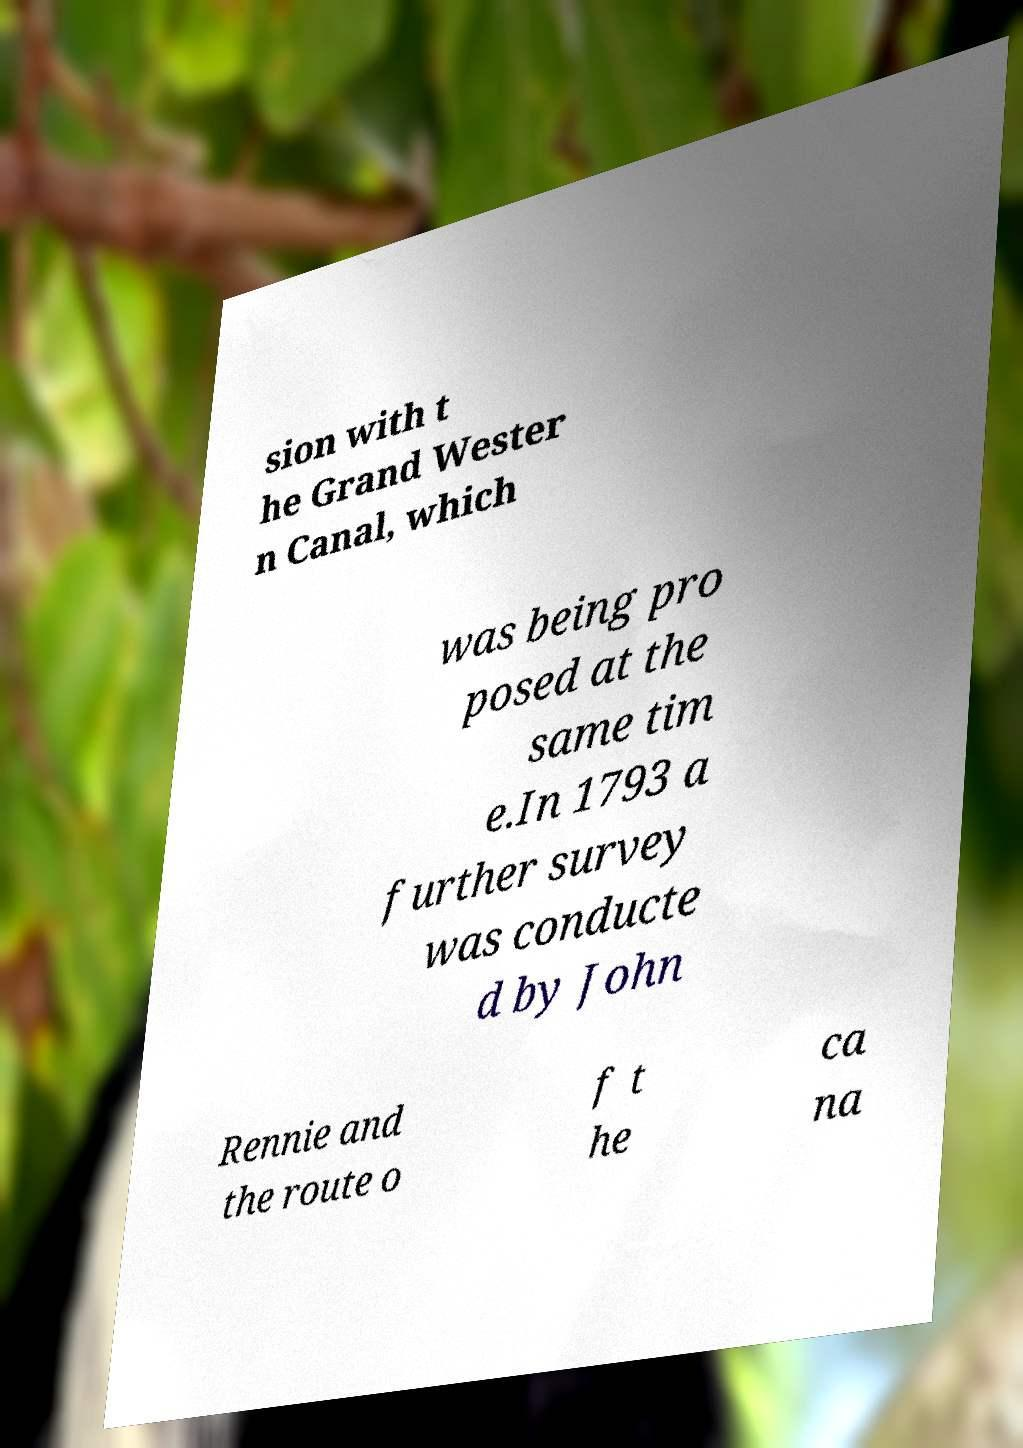I need the written content from this picture converted into text. Can you do that? sion with t he Grand Wester n Canal, which was being pro posed at the same tim e.In 1793 a further survey was conducte d by John Rennie and the route o f t he ca na 